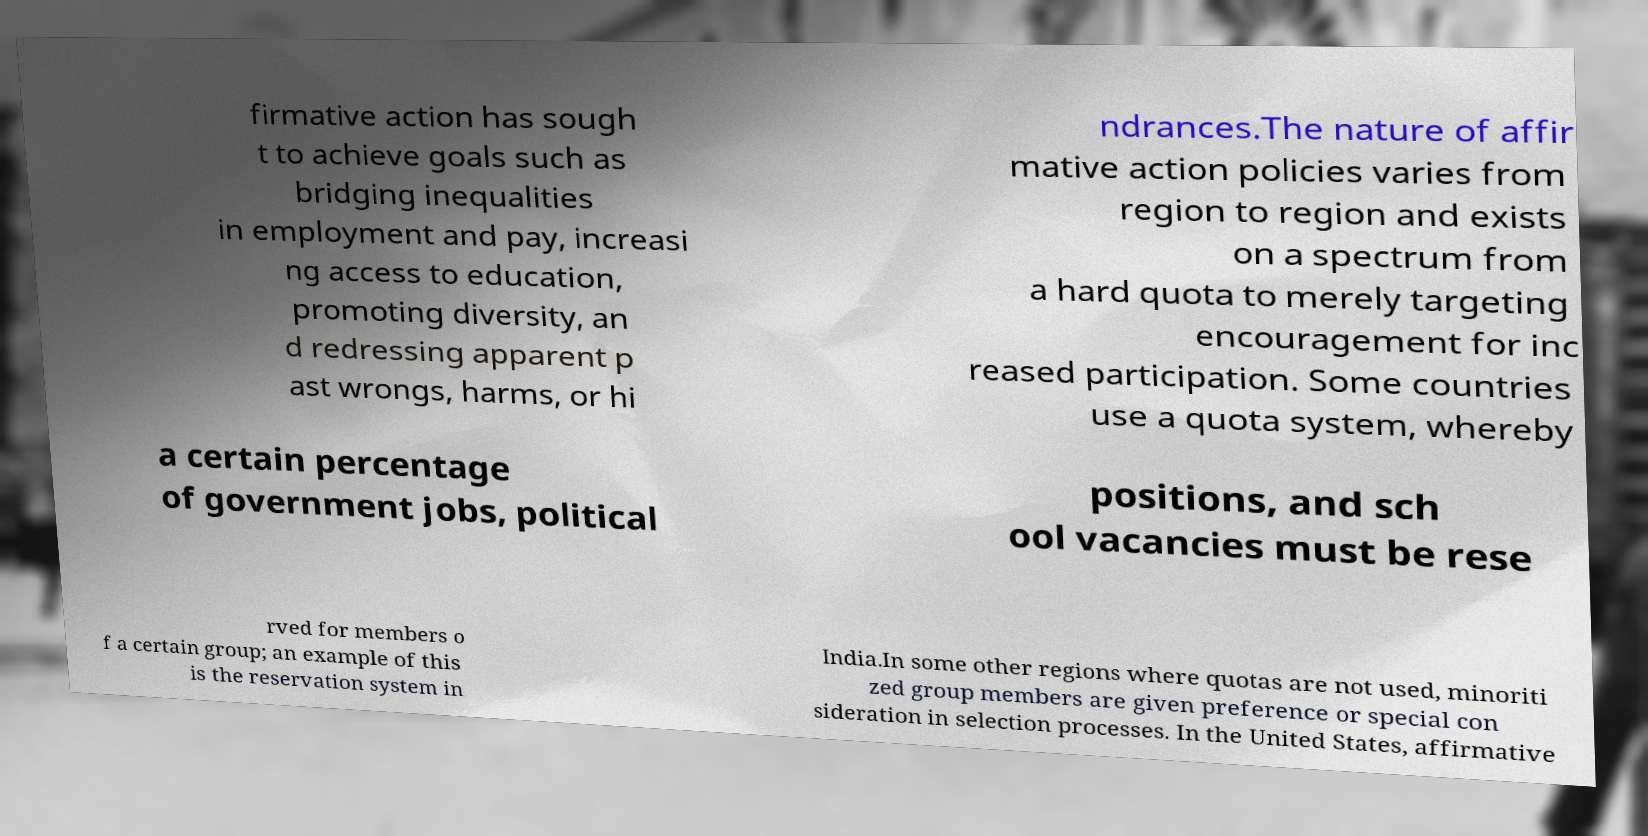Please read and relay the text visible in this image. What does it say? firmative action has sough t to achieve goals such as bridging inequalities in employment and pay, increasi ng access to education, promoting diversity, an d redressing apparent p ast wrongs, harms, or hi ndrances.The nature of affir mative action policies varies from region to region and exists on a spectrum from a hard quota to merely targeting encouragement for inc reased participation. Some countries use a quota system, whereby a certain percentage of government jobs, political positions, and sch ool vacancies must be rese rved for members o f a certain group; an example of this is the reservation system in India.In some other regions where quotas are not used, minoriti zed group members are given preference or special con sideration in selection processes. In the United States, affirmative 